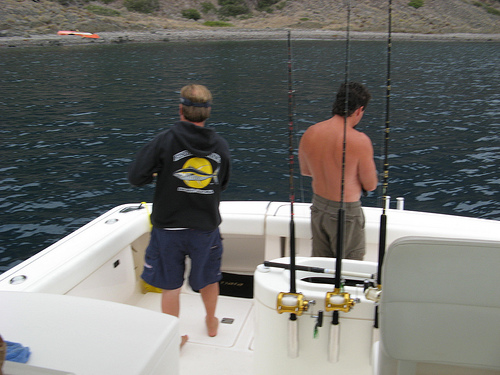<image>
Is there a fishing pole to the right of the man? Yes. From this viewpoint, the fishing pole is positioned to the right side relative to the man. Is the man in front of the fishing pole? No. The man is not in front of the fishing pole. The spatial positioning shows a different relationship between these objects. 